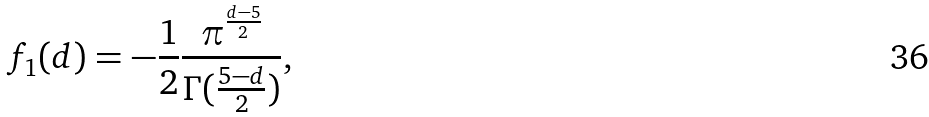<formula> <loc_0><loc_0><loc_500><loc_500>f _ { 1 } ( d ) = - \frac { 1 } { 2 } \frac { \pi ^ { \frac { d - 5 } { 2 } } } { \Gamma ( \frac { 5 - d } { 2 } ) } ,</formula> 